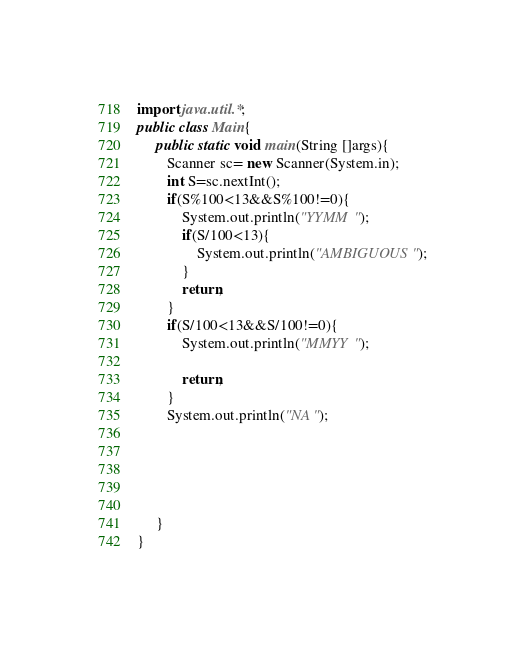<code> <loc_0><loc_0><loc_500><loc_500><_Java_>import java.util.*;
public class Main{
     public static void main(String []args){
        Scanner sc= new Scanner(System.in);
        int S=sc.nextInt();
        if(S%100<13&&S%100!=0){
            System.out.println("YYMM");
            if(S/100<13){
                System.out.println("AMBIGUOUS");
            }
            return;
        }
        if(S/100<13&&S/100!=0){
            System.out.println("MMYY");
        
            return;
        }
        System.out.println("NA");
        
        
        
        
        
     }
}</code> 